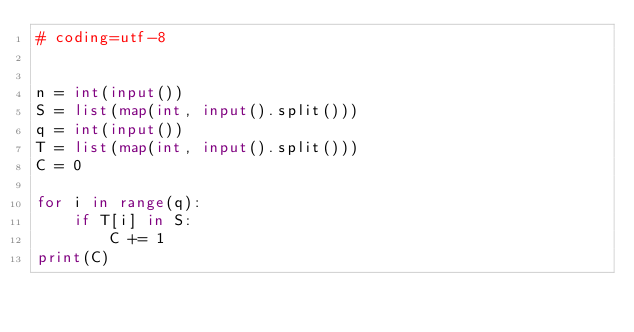Convert code to text. <code><loc_0><loc_0><loc_500><loc_500><_Python_># coding=utf-8


n = int(input())
S = list(map(int, input().split()))
q = int(input())
T = list(map(int, input().split()))
C = 0

for i in range(q):
    if T[i] in S:
        C += 1
print(C)</code> 